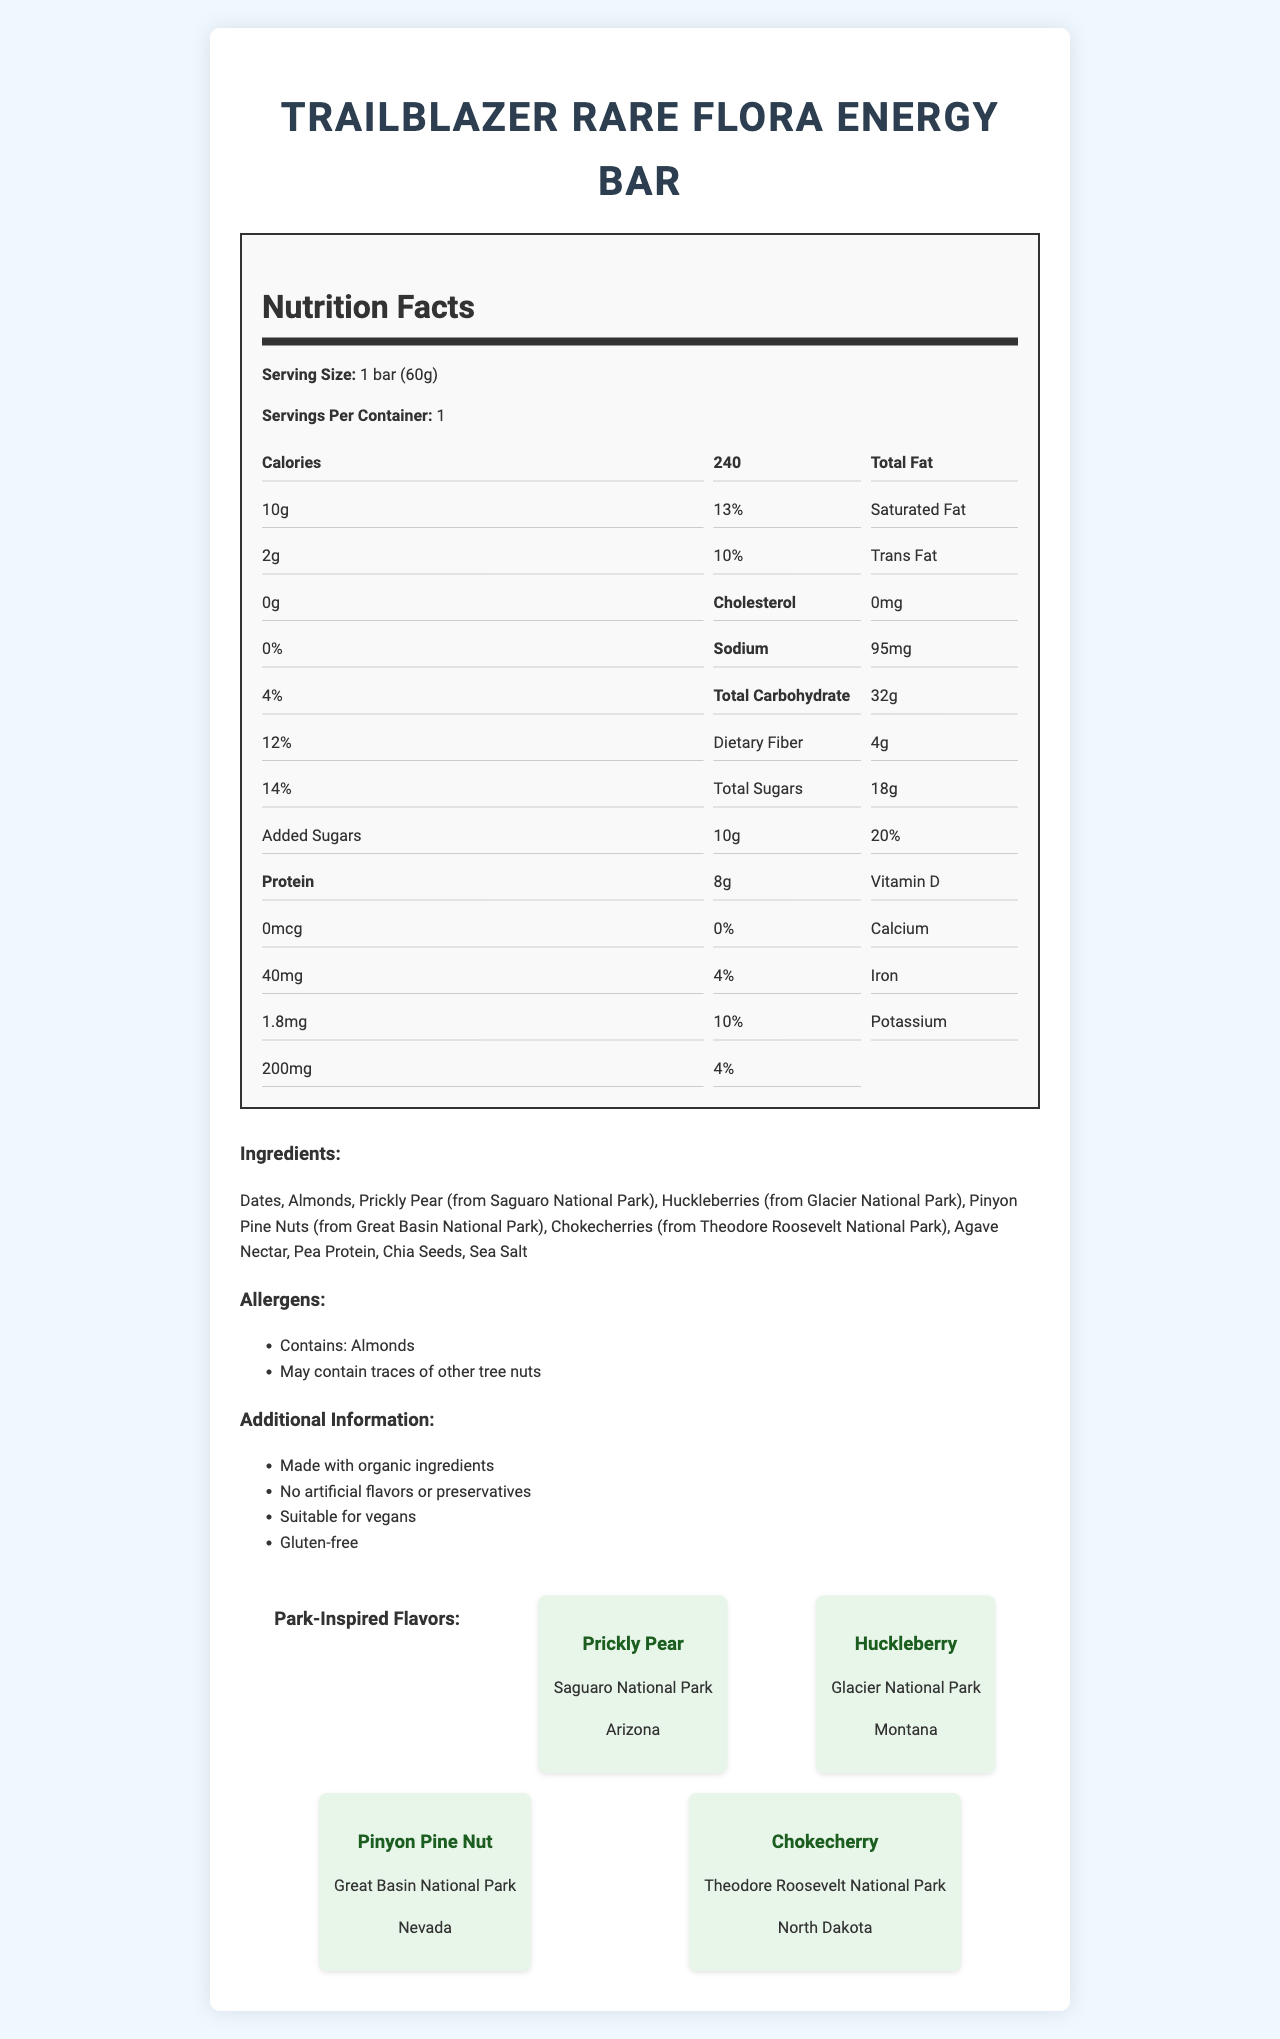what is the serving size of the TrailBlazer Rare Flora Energy Bar? The serving size is clearly listed near the top of the nutrition label as "Serving Size: 1 bar (60g)".
Answer: 1 bar (60g) how many flavors are inspired by national parks? The "Park-Inspired Flavors" section lists four flavors each associated with a different national park.
Answer: 4 what amount of dietary fiber does the energy bar contain? The amount of dietary fiber is listed under the "Total Carbohydrate" section in the nutrition label as 4g.
Answer: 4g how many total fats are present in this energy bar? The total fat content is listed as 10g on the nutrition facts label.
Answer: 10g what are the listed allergens for this energy bar? The allergens are mentioned in a dedicated section titled "Allergens".
Answer: Contains: Almonds, May contain traces of other tree nuts which park flavor comes from Glacier National Park? A. Prickly Pear B. Huckleberry C. Pinyon Pine Nut D. Chokecherry The "Park-Inspired Flavors" section identifies Huckleberry as the flavor from Glacier National Park.
Answer: B. Huckleberry how much iron does one serving of the energy bar have? A. 0.8mg B. 1.0mg C. 1.8mg D. 2.0mg The amount of iron is listed on the nutrition label under "Iron: 1.8mg (10%)"
Answer: C. 1.8mg is this energy bar suitable for vegans? The "Additional Information" section states that the energy bar is suitable for vegans.
Answer: Yes what is the main idea of the document? The main idea is to inform consumers about the nutritional content, ingredients, and unique flavors of the energy bar, emphasizing its connection to national parks and its suitability for specific dietary preferences.
Answer: The document provides detailed nutritional information, ingredients, allergens, and special attributes of the TrailBlazer Rare Flora Energy Bar, which includes flavors inspired by rare plants from various national parks. what preservatives are used in this energy bar? The "Additional Information" section states that there are no artificial preservatives, but it doesn't mention any natural preservatives that might be used.
Answer: Not enough information what are the total calories in the energy bar? The total calorie count is listed at the top of the nutrition label as 240.
Answer: 240 what state is associated with the Pinyon Pine Nut flavor? The "Park-Inspired Flavors" section lists Great Basin National Park in Nevada as the source of the Pinyon Pine Nut flavor.
Answer: Nevada how much sugar is added to the energy bar? The amount of added sugars is noted under the "Added Sugars" section in the nutrition label.
Answer: 10g is the energy bar gluten-free? The "Additional Information" section states that the energy bar is gluten-free.
Answer: Yes what vitamins are present in this energy bar? The nutrition label shows 0% for Vitamin D, implying there are no vitamins present.
Answer: None what portion of the daily value of saturated fat does the bar provide? The nutrition label indicates that the bar provides 10% of the daily value of saturated fat.
Answer: 10% 